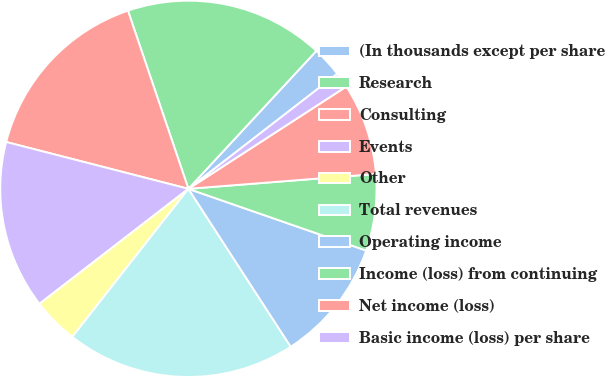Convert chart to OTSL. <chart><loc_0><loc_0><loc_500><loc_500><pie_chart><fcel>(In thousands except per share<fcel>Research<fcel>Consulting<fcel>Events<fcel>Other<fcel>Total revenues<fcel>Operating income<fcel>Income (loss) from continuing<fcel>Net income (loss)<fcel>Basic income (loss) per share<nl><fcel>2.63%<fcel>17.11%<fcel>15.79%<fcel>14.47%<fcel>3.95%<fcel>19.74%<fcel>10.53%<fcel>6.58%<fcel>7.89%<fcel>1.32%<nl></chart> 